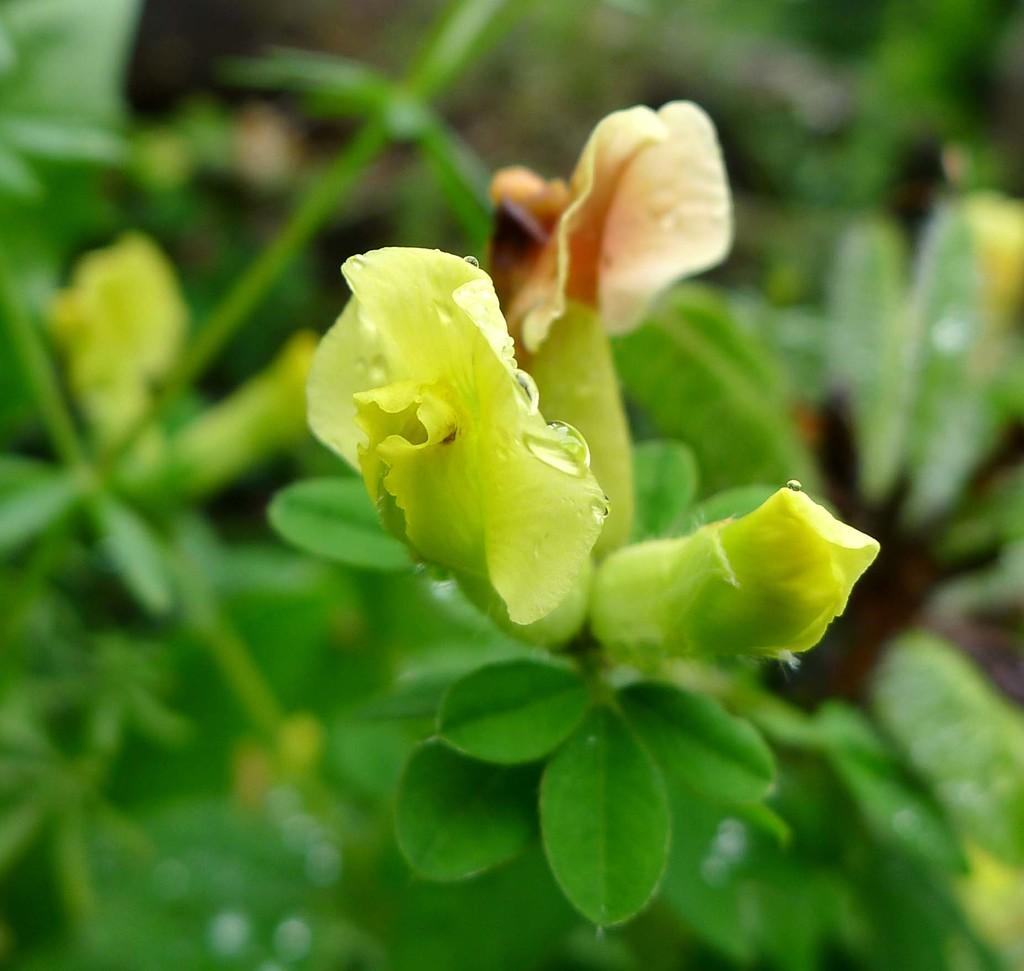What type of plant is visible in the image? The image features a plant with a flower on it. What other parts of the plant can be seen in the image? Leaves are visible at the bottom of the image. What type of whistle is being offered by the plant in the image? There is no whistle present in the image; it is a plant with a flower and leaves. 